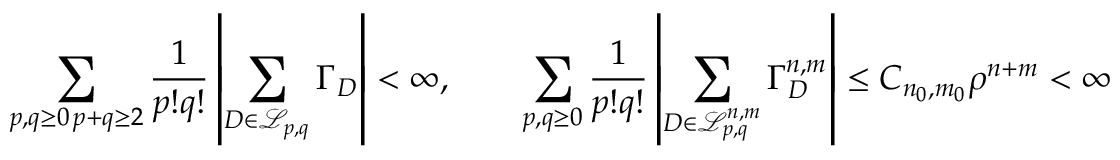<formula> <loc_0><loc_0><loc_500><loc_500>\sum _ { \substack { p , q \geq 0 \, p + q \geq 2 } } \frac { 1 } { p ! q ! } \left | \sum _ { D \in \mathcal { L } _ { p , q } } \Gamma _ { D } \right | < \infty , \quad \sum _ { p , q \geq 0 } \frac { 1 } { p ! q ! } \left | \sum _ { D \in \mathcal { L } _ { p , q } ^ { n , m } } \Gamma _ { D } ^ { n , m } \right | \leq C _ { n _ { 0 } , m _ { 0 } } \rho ^ { n + m } < \infty</formula> 